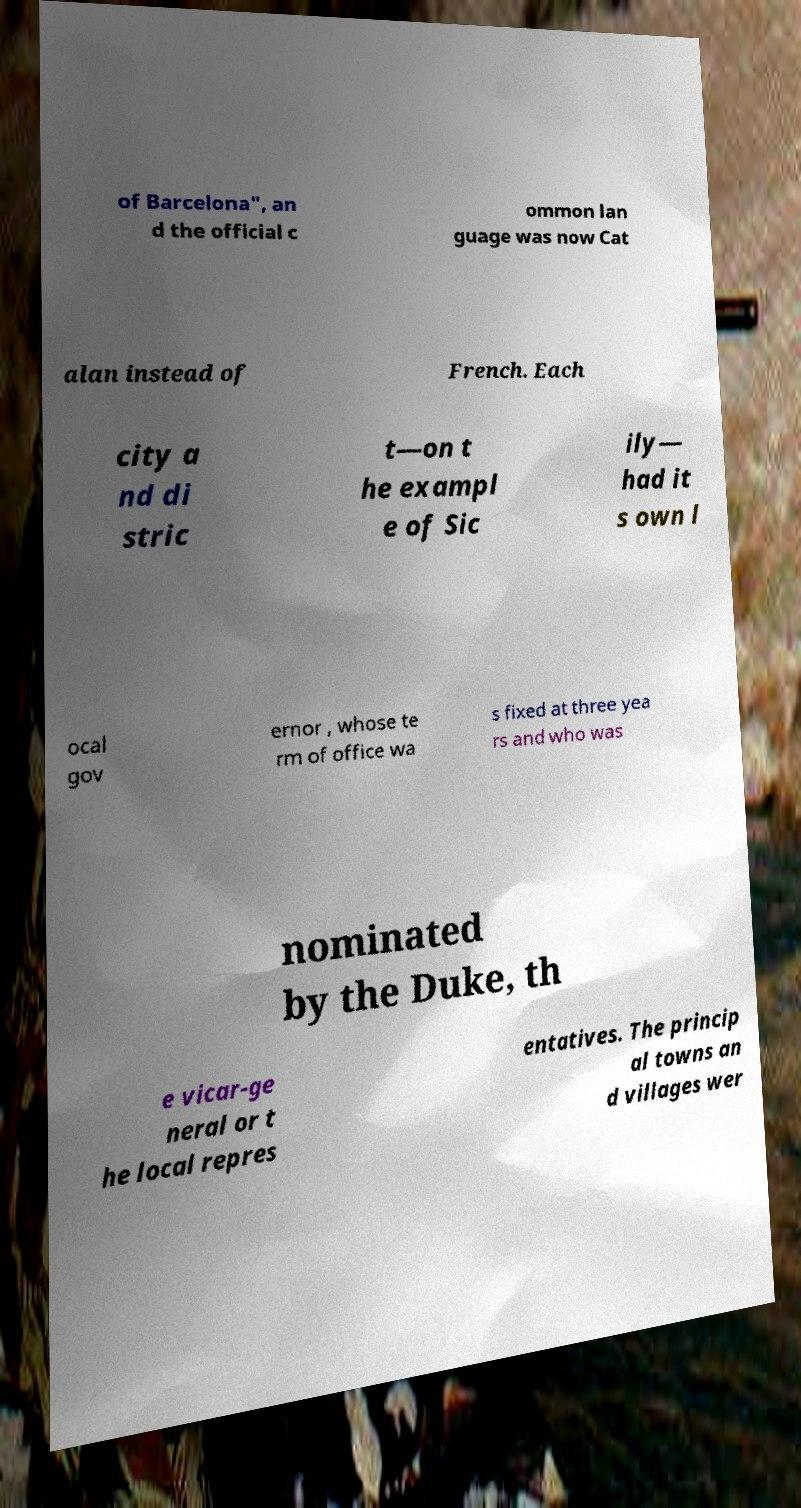There's text embedded in this image that I need extracted. Can you transcribe it verbatim? of Barcelona", an d the official c ommon lan guage was now Cat alan instead of French. Each city a nd di stric t—on t he exampl e of Sic ily— had it s own l ocal gov ernor , whose te rm of office wa s fixed at three yea rs and who was nominated by the Duke, th e vicar-ge neral or t he local repres entatives. The princip al towns an d villages wer 